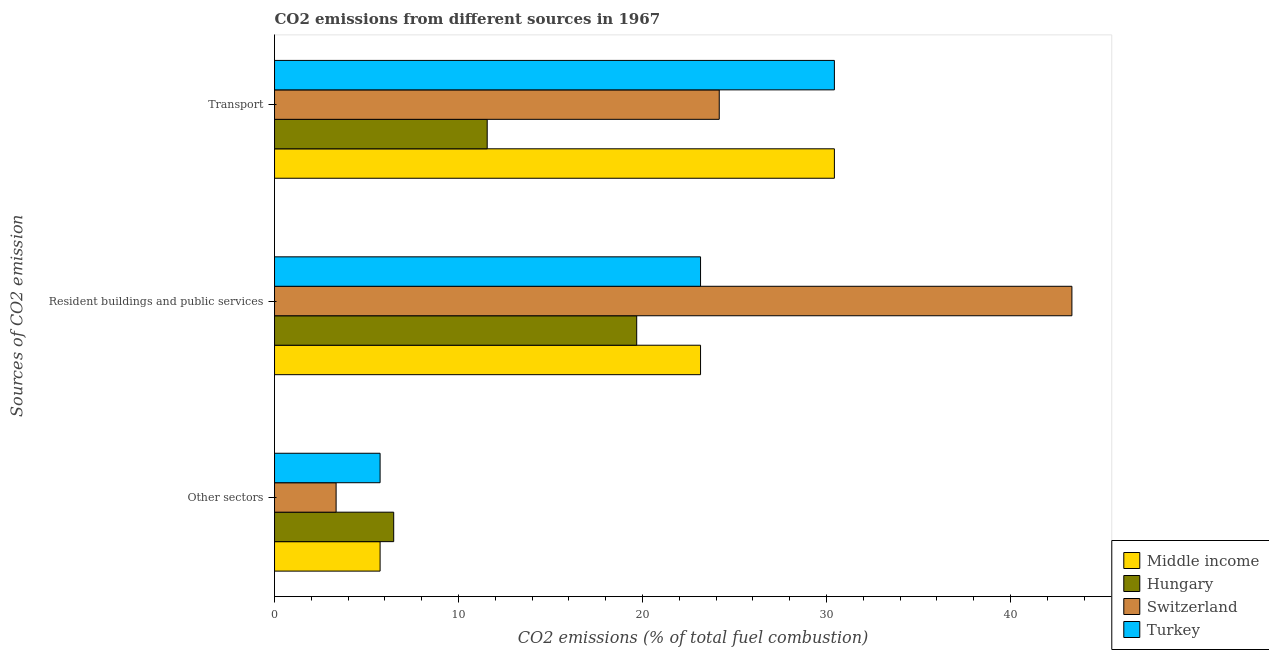How many different coloured bars are there?
Offer a terse response. 4. What is the label of the 3rd group of bars from the top?
Keep it short and to the point. Other sectors. What is the percentage of co2 emissions from transport in Turkey?
Make the answer very short. 30.43. Across all countries, what is the maximum percentage of co2 emissions from other sectors?
Your response must be concise. 6.48. Across all countries, what is the minimum percentage of co2 emissions from transport?
Offer a very short reply. 11.56. In which country was the percentage of co2 emissions from resident buildings and public services maximum?
Offer a terse response. Switzerland. In which country was the percentage of co2 emissions from transport minimum?
Provide a succinct answer. Hungary. What is the total percentage of co2 emissions from resident buildings and public services in the graph?
Offer a terse response. 109.34. What is the difference between the percentage of co2 emissions from transport in Middle income and the percentage of co2 emissions from other sectors in Turkey?
Give a very brief answer. 24.69. What is the average percentage of co2 emissions from resident buildings and public services per country?
Your answer should be compact. 27.33. What is the difference between the percentage of co2 emissions from transport and percentage of co2 emissions from resident buildings and public services in Switzerland?
Your response must be concise. -19.17. What is the ratio of the percentage of co2 emissions from other sectors in Middle income to that in Switzerland?
Provide a succinct answer. 1.71. Is the percentage of co2 emissions from transport in Middle income less than that in Hungary?
Ensure brevity in your answer.  No. Is the difference between the percentage of co2 emissions from transport in Hungary and Turkey greater than the difference between the percentage of co2 emissions from resident buildings and public services in Hungary and Turkey?
Give a very brief answer. No. What is the difference between the highest and the second highest percentage of co2 emissions from other sectors?
Ensure brevity in your answer.  0.74. What is the difference between the highest and the lowest percentage of co2 emissions from resident buildings and public services?
Your response must be concise. 23.65. In how many countries, is the percentage of co2 emissions from resident buildings and public services greater than the average percentage of co2 emissions from resident buildings and public services taken over all countries?
Your answer should be compact. 1. What does the 3rd bar from the top in Resident buildings and public services represents?
Ensure brevity in your answer.  Hungary. What does the 3rd bar from the bottom in Other sectors represents?
Your answer should be very brief. Switzerland. Is it the case that in every country, the sum of the percentage of co2 emissions from other sectors and percentage of co2 emissions from resident buildings and public services is greater than the percentage of co2 emissions from transport?
Provide a succinct answer. No. Are all the bars in the graph horizontal?
Keep it short and to the point. Yes. How many countries are there in the graph?
Keep it short and to the point. 4. Are the values on the major ticks of X-axis written in scientific E-notation?
Provide a short and direct response. No. Does the graph contain grids?
Provide a succinct answer. No. Where does the legend appear in the graph?
Provide a short and direct response. Bottom right. How many legend labels are there?
Offer a terse response. 4. What is the title of the graph?
Give a very brief answer. CO2 emissions from different sources in 1967. Does "Armenia" appear as one of the legend labels in the graph?
Offer a very short reply. No. What is the label or title of the X-axis?
Your answer should be compact. CO2 emissions (% of total fuel combustion). What is the label or title of the Y-axis?
Your answer should be very brief. Sources of CO2 emission. What is the CO2 emissions (% of total fuel combustion) in Middle income in Other sectors?
Keep it short and to the point. 5.74. What is the CO2 emissions (% of total fuel combustion) in Hungary in Other sectors?
Your answer should be compact. 6.48. What is the CO2 emissions (% of total fuel combustion) in Switzerland in Other sectors?
Your response must be concise. 3.35. What is the CO2 emissions (% of total fuel combustion) of Turkey in Other sectors?
Your answer should be compact. 5.74. What is the CO2 emissions (% of total fuel combustion) in Middle income in Resident buildings and public services?
Provide a short and direct response. 23.16. What is the CO2 emissions (% of total fuel combustion) in Hungary in Resident buildings and public services?
Provide a succinct answer. 19.69. What is the CO2 emissions (% of total fuel combustion) in Switzerland in Resident buildings and public services?
Provide a short and direct response. 43.34. What is the CO2 emissions (% of total fuel combustion) of Turkey in Resident buildings and public services?
Keep it short and to the point. 23.16. What is the CO2 emissions (% of total fuel combustion) in Middle income in Transport?
Offer a terse response. 30.43. What is the CO2 emissions (% of total fuel combustion) in Hungary in Transport?
Ensure brevity in your answer.  11.56. What is the CO2 emissions (% of total fuel combustion) of Switzerland in Transport?
Keep it short and to the point. 24.17. What is the CO2 emissions (% of total fuel combustion) of Turkey in Transport?
Your response must be concise. 30.43. Across all Sources of CO2 emission, what is the maximum CO2 emissions (% of total fuel combustion) in Middle income?
Keep it short and to the point. 30.43. Across all Sources of CO2 emission, what is the maximum CO2 emissions (% of total fuel combustion) of Hungary?
Your answer should be very brief. 19.69. Across all Sources of CO2 emission, what is the maximum CO2 emissions (% of total fuel combustion) of Switzerland?
Your answer should be very brief. 43.34. Across all Sources of CO2 emission, what is the maximum CO2 emissions (% of total fuel combustion) of Turkey?
Provide a short and direct response. 30.43. Across all Sources of CO2 emission, what is the minimum CO2 emissions (% of total fuel combustion) in Middle income?
Your answer should be compact. 5.74. Across all Sources of CO2 emission, what is the minimum CO2 emissions (% of total fuel combustion) in Hungary?
Your answer should be very brief. 6.48. Across all Sources of CO2 emission, what is the minimum CO2 emissions (% of total fuel combustion) in Switzerland?
Make the answer very short. 3.35. Across all Sources of CO2 emission, what is the minimum CO2 emissions (% of total fuel combustion) of Turkey?
Give a very brief answer. 5.74. What is the total CO2 emissions (% of total fuel combustion) in Middle income in the graph?
Ensure brevity in your answer.  59.32. What is the total CO2 emissions (% of total fuel combustion) of Hungary in the graph?
Provide a short and direct response. 37.72. What is the total CO2 emissions (% of total fuel combustion) of Switzerland in the graph?
Give a very brief answer. 70.86. What is the total CO2 emissions (% of total fuel combustion) of Turkey in the graph?
Make the answer very short. 59.32. What is the difference between the CO2 emissions (% of total fuel combustion) of Middle income in Other sectors and that in Resident buildings and public services?
Provide a succinct answer. -17.42. What is the difference between the CO2 emissions (% of total fuel combustion) of Hungary in Other sectors and that in Resident buildings and public services?
Give a very brief answer. -13.21. What is the difference between the CO2 emissions (% of total fuel combustion) in Switzerland in Other sectors and that in Resident buildings and public services?
Provide a short and direct response. -39.99. What is the difference between the CO2 emissions (% of total fuel combustion) in Turkey in Other sectors and that in Resident buildings and public services?
Make the answer very short. -17.42. What is the difference between the CO2 emissions (% of total fuel combustion) of Middle income in Other sectors and that in Transport?
Offer a very short reply. -24.69. What is the difference between the CO2 emissions (% of total fuel combustion) in Hungary in Other sectors and that in Transport?
Your answer should be very brief. -5.08. What is the difference between the CO2 emissions (% of total fuel combustion) of Switzerland in Other sectors and that in Transport?
Provide a succinct answer. -20.82. What is the difference between the CO2 emissions (% of total fuel combustion) in Turkey in Other sectors and that in Transport?
Give a very brief answer. -24.69. What is the difference between the CO2 emissions (% of total fuel combustion) of Middle income in Resident buildings and public services and that in Transport?
Provide a short and direct response. -7.27. What is the difference between the CO2 emissions (% of total fuel combustion) of Hungary in Resident buildings and public services and that in Transport?
Your answer should be compact. 8.13. What is the difference between the CO2 emissions (% of total fuel combustion) in Switzerland in Resident buildings and public services and that in Transport?
Your answer should be very brief. 19.17. What is the difference between the CO2 emissions (% of total fuel combustion) in Turkey in Resident buildings and public services and that in Transport?
Your answer should be compact. -7.27. What is the difference between the CO2 emissions (% of total fuel combustion) in Middle income in Other sectors and the CO2 emissions (% of total fuel combustion) in Hungary in Resident buildings and public services?
Make the answer very short. -13.95. What is the difference between the CO2 emissions (% of total fuel combustion) in Middle income in Other sectors and the CO2 emissions (% of total fuel combustion) in Switzerland in Resident buildings and public services?
Give a very brief answer. -37.6. What is the difference between the CO2 emissions (% of total fuel combustion) in Middle income in Other sectors and the CO2 emissions (% of total fuel combustion) in Turkey in Resident buildings and public services?
Keep it short and to the point. -17.42. What is the difference between the CO2 emissions (% of total fuel combustion) in Hungary in Other sectors and the CO2 emissions (% of total fuel combustion) in Switzerland in Resident buildings and public services?
Provide a short and direct response. -36.86. What is the difference between the CO2 emissions (% of total fuel combustion) of Hungary in Other sectors and the CO2 emissions (% of total fuel combustion) of Turkey in Resident buildings and public services?
Ensure brevity in your answer.  -16.68. What is the difference between the CO2 emissions (% of total fuel combustion) in Switzerland in Other sectors and the CO2 emissions (% of total fuel combustion) in Turkey in Resident buildings and public services?
Ensure brevity in your answer.  -19.81. What is the difference between the CO2 emissions (% of total fuel combustion) of Middle income in Other sectors and the CO2 emissions (% of total fuel combustion) of Hungary in Transport?
Your answer should be very brief. -5.82. What is the difference between the CO2 emissions (% of total fuel combustion) of Middle income in Other sectors and the CO2 emissions (% of total fuel combustion) of Switzerland in Transport?
Offer a very short reply. -18.43. What is the difference between the CO2 emissions (% of total fuel combustion) of Middle income in Other sectors and the CO2 emissions (% of total fuel combustion) of Turkey in Transport?
Make the answer very short. -24.69. What is the difference between the CO2 emissions (% of total fuel combustion) of Hungary in Other sectors and the CO2 emissions (% of total fuel combustion) of Switzerland in Transport?
Make the answer very short. -17.69. What is the difference between the CO2 emissions (% of total fuel combustion) of Hungary in Other sectors and the CO2 emissions (% of total fuel combustion) of Turkey in Transport?
Offer a terse response. -23.95. What is the difference between the CO2 emissions (% of total fuel combustion) in Switzerland in Other sectors and the CO2 emissions (% of total fuel combustion) in Turkey in Transport?
Give a very brief answer. -27.08. What is the difference between the CO2 emissions (% of total fuel combustion) of Middle income in Resident buildings and public services and the CO2 emissions (% of total fuel combustion) of Hungary in Transport?
Provide a succinct answer. 11.6. What is the difference between the CO2 emissions (% of total fuel combustion) of Middle income in Resident buildings and public services and the CO2 emissions (% of total fuel combustion) of Switzerland in Transport?
Your answer should be very brief. -1.02. What is the difference between the CO2 emissions (% of total fuel combustion) of Middle income in Resident buildings and public services and the CO2 emissions (% of total fuel combustion) of Turkey in Transport?
Offer a very short reply. -7.27. What is the difference between the CO2 emissions (% of total fuel combustion) in Hungary in Resident buildings and public services and the CO2 emissions (% of total fuel combustion) in Switzerland in Transport?
Your answer should be very brief. -4.49. What is the difference between the CO2 emissions (% of total fuel combustion) of Hungary in Resident buildings and public services and the CO2 emissions (% of total fuel combustion) of Turkey in Transport?
Provide a succinct answer. -10.74. What is the difference between the CO2 emissions (% of total fuel combustion) of Switzerland in Resident buildings and public services and the CO2 emissions (% of total fuel combustion) of Turkey in Transport?
Offer a very short reply. 12.91. What is the average CO2 emissions (% of total fuel combustion) of Middle income per Sources of CO2 emission?
Provide a succinct answer. 19.77. What is the average CO2 emissions (% of total fuel combustion) in Hungary per Sources of CO2 emission?
Ensure brevity in your answer.  12.57. What is the average CO2 emissions (% of total fuel combustion) of Switzerland per Sources of CO2 emission?
Provide a short and direct response. 23.62. What is the average CO2 emissions (% of total fuel combustion) of Turkey per Sources of CO2 emission?
Give a very brief answer. 19.77. What is the difference between the CO2 emissions (% of total fuel combustion) of Middle income and CO2 emissions (% of total fuel combustion) of Hungary in Other sectors?
Provide a short and direct response. -0.74. What is the difference between the CO2 emissions (% of total fuel combustion) in Middle income and CO2 emissions (% of total fuel combustion) in Switzerland in Other sectors?
Your answer should be compact. 2.39. What is the difference between the CO2 emissions (% of total fuel combustion) of Middle income and CO2 emissions (% of total fuel combustion) of Turkey in Other sectors?
Your answer should be compact. 0. What is the difference between the CO2 emissions (% of total fuel combustion) of Hungary and CO2 emissions (% of total fuel combustion) of Switzerland in Other sectors?
Offer a terse response. 3.13. What is the difference between the CO2 emissions (% of total fuel combustion) in Hungary and CO2 emissions (% of total fuel combustion) in Turkey in Other sectors?
Offer a terse response. 0.74. What is the difference between the CO2 emissions (% of total fuel combustion) of Switzerland and CO2 emissions (% of total fuel combustion) of Turkey in Other sectors?
Your response must be concise. -2.39. What is the difference between the CO2 emissions (% of total fuel combustion) in Middle income and CO2 emissions (% of total fuel combustion) in Hungary in Resident buildings and public services?
Provide a succinct answer. 3.47. What is the difference between the CO2 emissions (% of total fuel combustion) in Middle income and CO2 emissions (% of total fuel combustion) in Switzerland in Resident buildings and public services?
Provide a succinct answer. -20.18. What is the difference between the CO2 emissions (% of total fuel combustion) in Middle income and CO2 emissions (% of total fuel combustion) in Turkey in Resident buildings and public services?
Provide a succinct answer. 0. What is the difference between the CO2 emissions (% of total fuel combustion) in Hungary and CO2 emissions (% of total fuel combustion) in Switzerland in Resident buildings and public services?
Offer a very short reply. -23.65. What is the difference between the CO2 emissions (% of total fuel combustion) of Hungary and CO2 emissions (% of total fuel combustion) of Turkey in Resident buildings and public services?
Offer a very short reply. -3.47. What is the difference between the CO2 emissions (% of total fuel combustion) of Switzerland and CO2 emissions (% of total fuel combustion) of Turkey in Resident buildings and public services?
Your response must be concise. 20.18. What is the difference between the CO2 emissions (% of total fuel combustion) in Middle income and CO2 emissions (% of total fuel combustion) in Hungary in Transport?
Ensure brevity in your answer.  18.87. What is the difference between the CO2 emissions (% of total fuel combustion) in Middle income and CO2 emissions (% of total fuel combustion) in Switzerland in Transport?
Offer a very short reply. 6.26. What is the difference between the CO2 emissions (% of total fuel combustion) of Hungary and CO2 emissions (% of total fuel combustion) of Switzerland in Transport?
Your response must be concise. -12.61. What is the difference between the CO2 emissions (% of total fuel combustion) in Hungary and CO2 emissions (% of total fuel combustion) in Turkey in Transport?
Provide a short and direct response. -18.87. What is the difference between the CO2 emissions (% of total fuel combustion) in Switzerland and CO2 emissions (% of total fuel combustion) in Turkey in Transport?
Make the answer very short. -6.26. What is the ratio of the CO2 emissions (% of total fuel combustion) in Middle income in Other sectors to that in Resident buildings and public services?
Keep it short and to the point. 0.25. What is the ratio of the CO2 emissions (% of total fuel combustion) of Hungary in Other sectors to that in Resident buildings and public services?
Your answer should be compact. 0.33. What is the ratio of the CO2 emissions (% of total fuel combustion) of Switzerland in Other sectors to that in Resident buildings and public services?
Provide a short and direct response. 0.08. What is the ratio of the CO2 emissions (% of total fuel combustion) in Turkey in Other sectors to that in Resident buildings and public services?
Offer a very short reply. 0.25. What is the ratio of the CO2 emissions (% of total fuel combustion) in Middle income in Other sectors to that in Transport?
Provide a succinct answer. 0.19. What is the ratio of the CO2 emissions (% of total fuel combustion) of Hungary in Other sectors to that in Transport?
Make the answer very short. 0.56. What is the ratio of the CO2 emissions (% of total fuel combustion) of Switzerland in Other sectors to that in Transport?
Offer a terse response. 0.14. What is the ratio of the CO2 emissions (% of total fuel combustion) of Turkey in Other sectors to that in Transport?
Provide a short and direct response. 0.19. What is the ratio of the CO2 emissions (% of total fuel combustion) in Middle income in Resident buildings and public services to that in Transport?
Keep it short and to the point. 0.76. What is the ratio of the CO2 emissions (% of total fuel combustion) of Hungary in Resident buildings and public services to that in Transport?
Offer a terse response. 1.7. What is the ratio of the CO2 emissions (% of total fuel combustion) in Switzerland in Resident buildings and public services to that in Transport?
Give a very brief answer. 1.79. What is the ratio of the CO2 emissions (% of total fuel combustion) of Turkey in Resident buildings and public services to that in Transport?
Ensure brevity in your answer.  0.76. What is the difference between the highest and the second highest CO2 emissions (% of total fuel combustion) of Middle income?
Offer a very short reply. 7.27. What is the difference between the highest and the second highest CO2 emissions (% of total fuel combustion) in Hungary?
Your answer should be compact. 8.13. What is the difference between the highest and the second highest CO2 emissions (% of total fuel combustion) in Switzerland?
Provide a short and direct response. 19.17. What is the difference between the highest and the second highest CO2 emissions (% of total fuel combustion) in Turkey?
Offer a very short reply. 7.27. What is the difference between the highest and the lowest CO2 emissions (% of total fuel combustion) in Middle income?
Ensure brevity in your answer.  24.69. What is the difference between the highest and the lowest CO2 emissions (% of total fuel combustion) in Hungary?
Offer a terse response. 13.21. What is the difference between the highest and the lowest CO2 emissions (% of total fuel combustion) in Switzerland?
Provide a short and direct response. 39.99. What is the difference between the highest and the lowest CO2 emissions (% of total fuel combustion) in Turkey?
Your response must be concise. 24.69. 